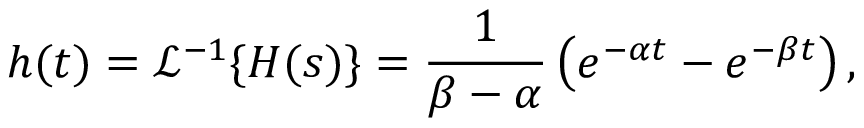Convert formula to latex. <formula><loc_0><loc_0><loc_500><loc_500>h ( t ) = { \mathcal { L } } ^ { - 1 } \{ H ( s ) \} = { \frac { 1 } { \beta - \alpha } } \left ( e ^ { - \alpha t } - e ^ { - \beta t } \right ) ,</formula> 